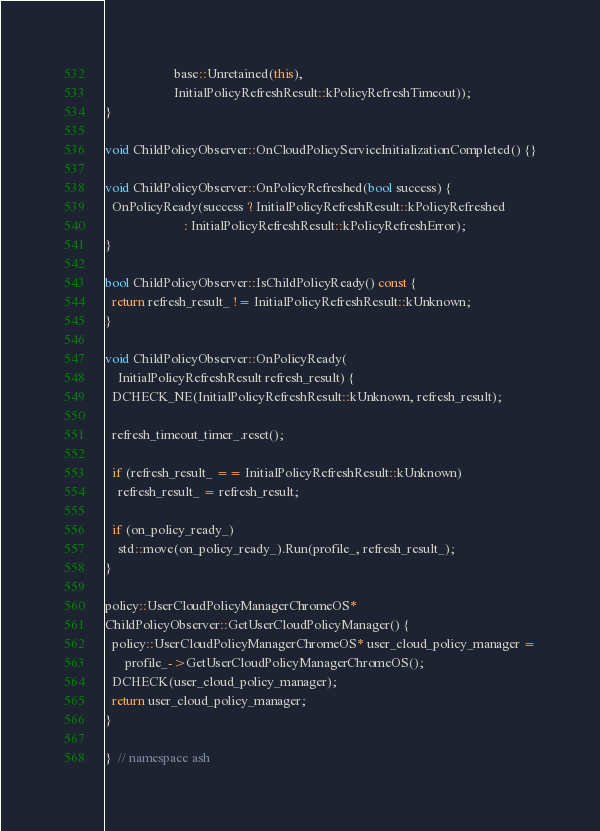<code> <loc_0><loc_0><loc_500><loc_500><_C++_>                     base::Unretained(this),
                     InitialPolicyRefreshResult::kPolicyRefreshTimeout));
}

void ChildPolicyObserver::OnCloudPolicyServiceInitializationCompleted() {}

void ChildPolicyObserver::OnPolicyRefreshed(bool success) {
  OnPolicyReady(success ? InitialPolicyRefreshResult::kPolicyRefreshed
                        : InitialPolicyRefreshResult::kPolicyRefreshError);
}

bool ChildPolicyObserver::IsChildPolicyReady() const {
  return refresh_result_ != InitialPolicyRefreshResult::kUnknown;
}

void ChildPolicyObserver::OnPolicyReady(
    InitialPolicyRefreshResult refresh_result) {
  DCHECK_NE(InitialPolicyRefreshResult::kUnknown, refresh_result);

  refresh_timeout_timer_.reset();

  if (refresh_result_ == InitialPolicyRefreshResult::kUnknown)
    refresh_result_ = refresh_result;

  if (on_policy_ready_)
    std::move(on_policy_ready_).Run(profile_, refresh_result_);
}

policy::UserCloudPolicyManagerChromeOS*
ChildPolicyObserver::GetUserCloudPolicyManager() {
  policy::UserCloudPolicyManagerChromeOS* user_cloud_policy_manager =
      profile_->GetUserCloudPolicyManagerChromeOS();
  DCHECK(user_cloud_policy_manager);
  return user_cloud_policy_manager;
}

}  // namespace ash
</code> 